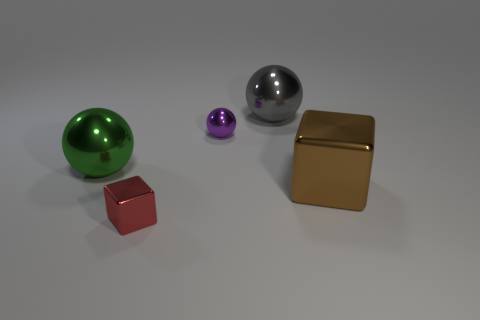Can you describe the lighting and shadows in the scene? The lighting in the image seems soft and diffused, coming from a direction that is not directly visible. It casts gentle shadows to the right of each object, indicating a light source positioned towards the left. The length and direction of the shadows suggest that the light source is at a moderate angle to the objects. The lighting gives the scene a calm, almost studio-like atmosphere. 